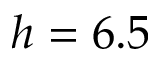<formula> <loc_0><loc_0><loc_500><loc_500>h = 6 . 5</formula> 